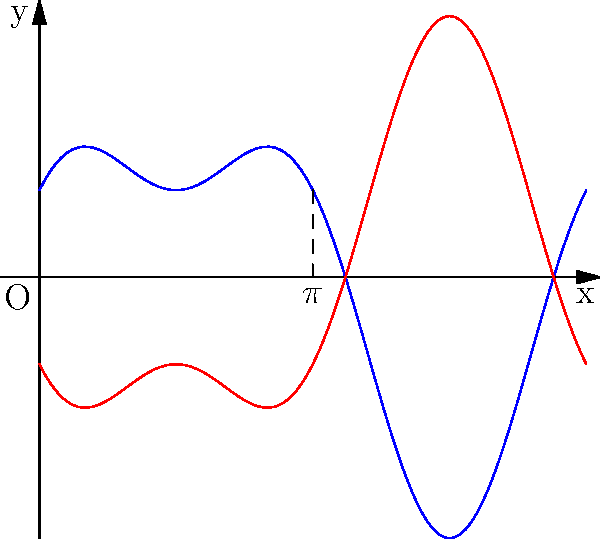The graph above represents a complex shibori design pattern in polar coordinates $(r,\theta)$, where $r = 2\sin(\theta) + \cos(2\theta)$ (blue curve) and its mirror image (red curve). Determine the order of rotational symmetry of this design about the origin. To determine the order of rotational symmetry, we need to follow these steps:

1. Observe the pattern's repetition: The blue curve repeats twice over the interval $[0, 2\pi]$, and the red curve is its mirror image.

2. Identify symmetry points: The design is symmetric about the x-axis (at $\theta = 0$ and $\theta = \pi$) and the y-axis (at $\theta = \frac{\pi}{2}$ and $\theta = \frac{3\pi}{2}$).

3. Count rotations: The design returns to its original position after rotations of $\frac{\pi}{2}$, $\pi$, $\frac{3\pi}{2}$, and $2\pi$.

4. Calculate order of symmetry: The number of distinct positions before returning to the original position is 4.

Therefore, the design has 4-fold rotational symmetry (order 4) about the origin.
Answer: 4 